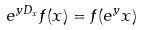<formula> <loc_0><loc_0><loc_500><loc_500>e ^ { y D _ { x } } f ( x ) = f ( e ^ { y } x )</formula> 